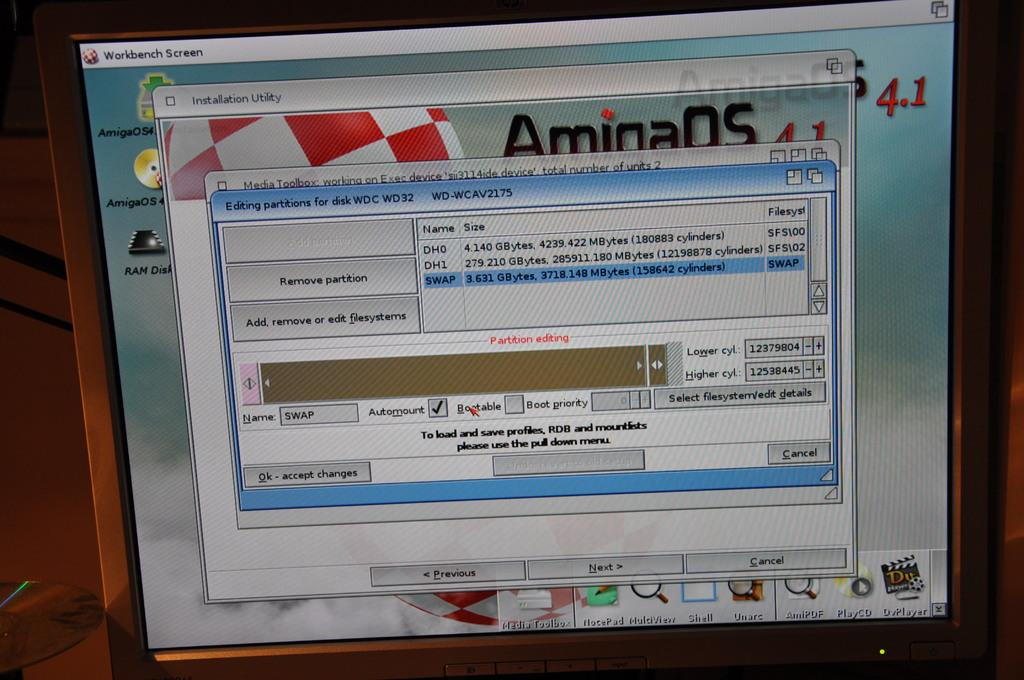<image>
Describe the image concisely. A computer screen has a program open that says Workbench Screen. 